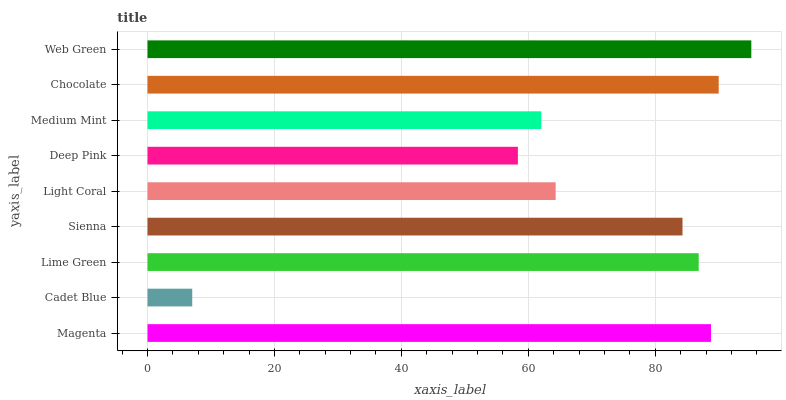Is Cadet Blue the minimum?
Answer yes or no. Yes. Is Web Green the maximum?
Answer yes or no. Yes. Is Lime Green the minimum?
Answer yes or no. No. Is Lime Green the maximum?
Answer yes or no. No. Is Lime Green greater than Cadet Blue?
Answer yes or no. Yes. Is Cadet Blue less than Lime Green?
Answer yes or no. Yes. Is Cadet Blue greater than Lime Green?
Answer yes or no. No. Is Lime Green less than Cadet Blue?
Answer yes or no. No. Is Sienna the high median?
Answer yes or no. Yes. Is Sienna the low median?
Answer yes or no. Yes. Is Magenta the high median?
Answer yes or no. No. Is Cadet Blue the low median?
Answer yes or no. No. 